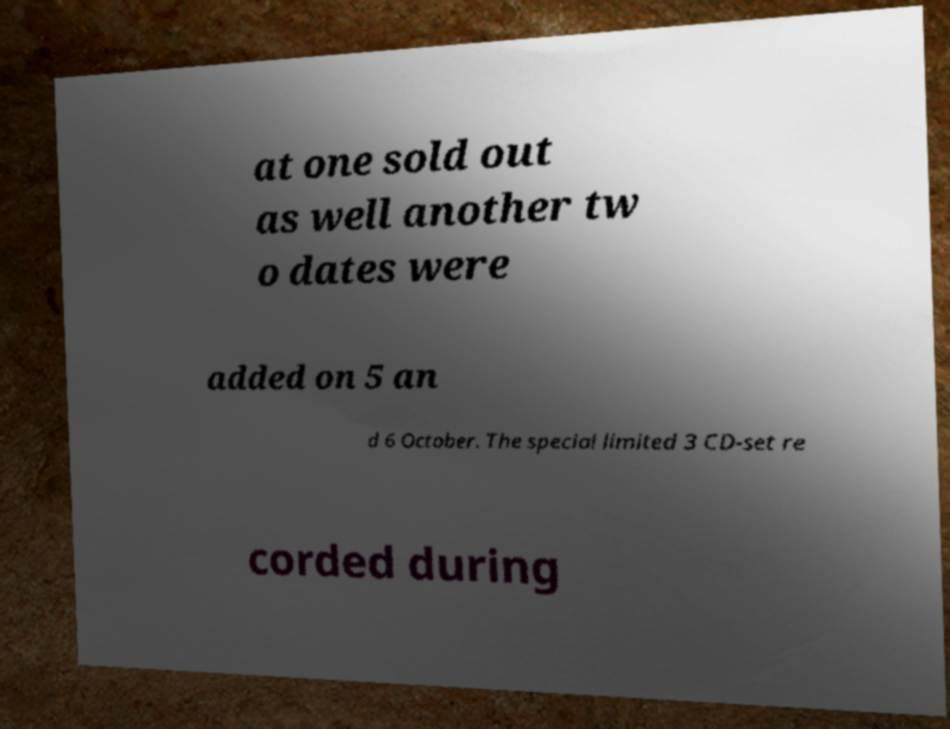I need the written content from this picture converted into text. Can you do that? at one sold out as well another tw o dates were added on 5 an d 6 October. The special limited 3 CD-set re corded during 